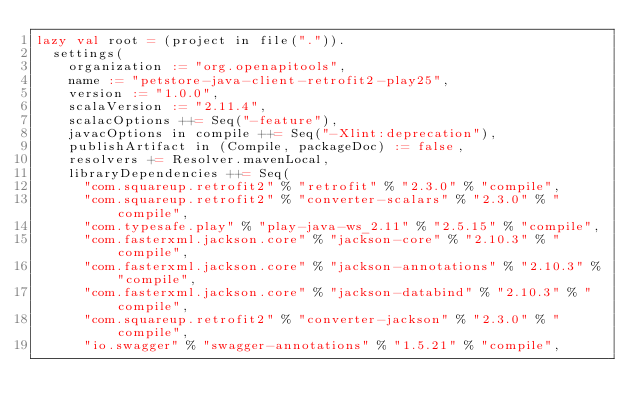Convert code to text. <code><loc_0><loc_0><loc_500><loc_500><_Scala_>lazy val root = (project in file(".")).
  settings(
    organization := "org.openapitools",
    name := "petstore-java-client-retrofit2-play25",
    version := "1.0.0",
    scalaVersion := "2.11.4",
    scalacOptions ++= Seq("-feature"),
    javacOptions in compile ++= Seq("-Xlint:deprecation"),
    publishArtifact in (Compile, packageDoc) := false,
    resolvers += Resolver.mavenLocal,
    libraryDependencies ++= Seq(
      "com.squareup.retrofit2" % "retrofit" % "2.3.0" % "compile",
      "com.squareup.retrofit2" % "converter-scalars" % "2.3.0" % "compile",
      "com.typesafe.play" % "play-java-ws_2.11" % "2.5.15" % "compile",
      "com.fasterxml.jackson.core" % "jackson-core" % "2.10.3" % "compile",
      "com.fasterxml.jackson.core" % "jackson-annotations" % "2.10.3" % "compile",
      "com.fasterxml.jackson.core" % "jackson-databind" % "2.10.3" % "compile",
      "com.squareup.retrofit2" % "converter-jackson" % "2.3.0" % "compile",
      "io.swagger" % "swagger-annotations" % "1.5.21" % "compile",</code> 